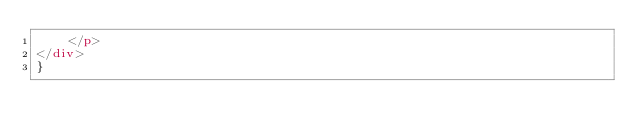<code> <loc_0><loc_0><loc_500><loc_500><_HTML_>    </p>
</div>
}</code> 